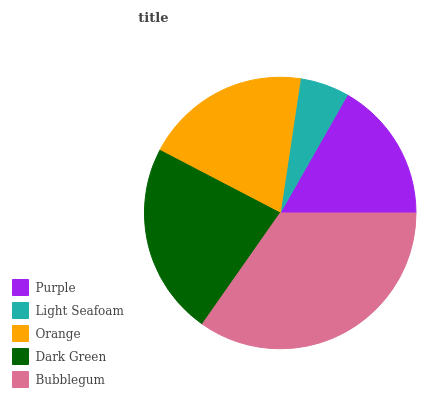Is Light Seafoam the minimum?
Answer yes or no. Yes. Is Bubblegum the maximum?
Answer yes or no. Yes. Is Orange the minimum?
Answer yes or no. No. Is Orange the maximum?
Answer yes or no. No. Is Orange greater than Light Seafoam?
Answer yes or no. Yes. Is Light Seafoam less than Orange?
Answer yes or no. Yes. Is Light Seafoam greater than Orange?
Answer yes or no. No. Is Orange less than Light Seafoam?
Answer yes or no. No. Is Orange the high median?
Answer yes or no. Yes. Is Orange the low median?
Answer yes or no. Yes. Is Bubblegum the high median?
Answer yes or no. No. Is Dark Green the low median?
Answer yes or no. No. 